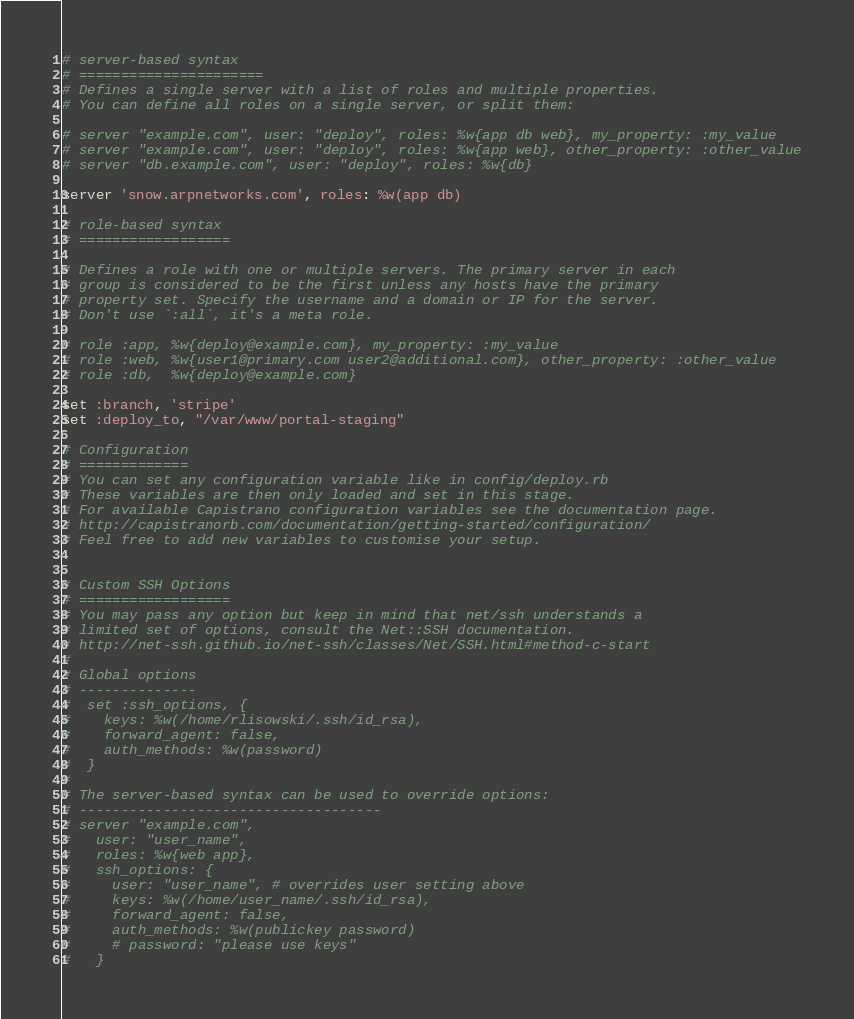<code> <loc_0><loc_0><loc_500><loc_500><_Ruby_># server-based syntax
# ======================
# Defines a single server with a list of roles and multiple properties.
# You can define all roles on a single server, or split them:

# server "example.com", user: "deploy", roles: %w{app db web}, my_property: :my_value
# server "example.com", user: "deploy", roles: %w{app web}, other_property: :other_value
# server "db.example.com", user: "deploy", roles: %w{db}

server 'snow.arpnetworks.com', roles: %w(app db)

# role-based syntax
# ==================

# Defines a role with one or multiple servers. The primary server in each
# group is considered to be the first unless any hosts have the primary
# property set. Specify the username and a domain or IP for the server.
# Don't use `:all`, it's a meta role.

# role :app, %w{deploy@example.com}, my_property: :my_value
# role :web, %w{user1@primary.com user2@additional.com}, other_property: :other_value
# role :db,  %w{deploy@example.com}

set :branch, 'stripe'
set :deploy_to, "/var/www/portal-staging"

# Configuration
# =============
# You can set any configuration variable like in config/deploy.rb
# These variables are then only loaded and set in this stage.
# For available Capistrano configuration variables see the documentation page.
# http://capistranorb.com/documentation/getting-started/configuration/
# Feel free to add new variables to customise your setup.


# Custom SSH Options
# ==================
# You may pass any option but keep in mind that net/ssh understands a
# limited set of options, consult the Net::SSH documentation.
# http://net-ssh.github.io/net-ssh/classes/Net/SSH.html#method-c-start
#
# Global options
# --------------
#  set :ssh_options, {
#    keys: %w(/home/rlisowski/.ssh/id_rsa),
#    forward_agent: false,
#    auth_methods: %w(password)
#  }
#
# The server-based syntax can be used to override options:
# ------------------------------------
# server "example.com",
#   user: "user_name",
#   roles: %w{web app},
#   ssh_options: {
#     user: "user_name", # overrides user setting above
#     keys: %w(/home/user_name/.ssh/id_rsa),
#     forward_agent: false,
#     auth_methods: %w(publickey password)
#     # password: "please use keys"
#   }
</code> 